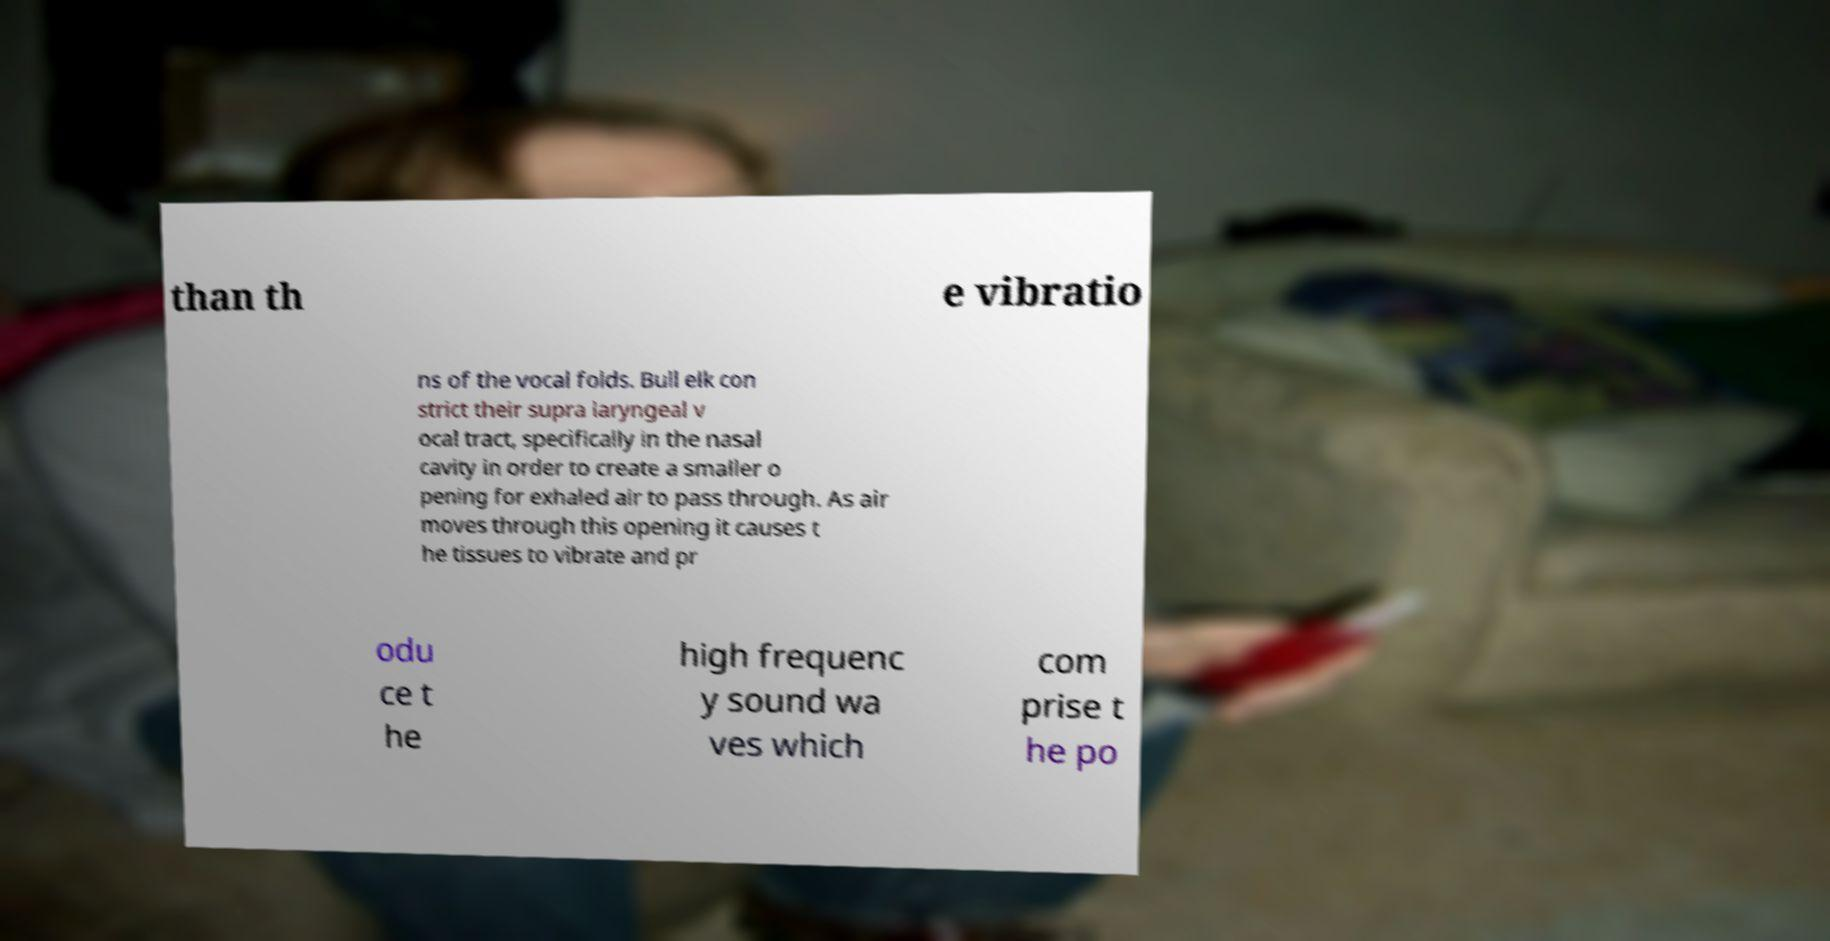Could you assist in decoding the text presented in this image and type it out clearly? than th e vibratio ns of the vocal folds. Bull elk con strict their supra laryngeal v ocal tract, specifically in the nasal cavity in order to create a smaller o pening for exhaled air to pass through. As air moves through this opening it causes t he tissues to vibrate and pr odu ce t he high frequenc y sound wa ves which com prise t he po 